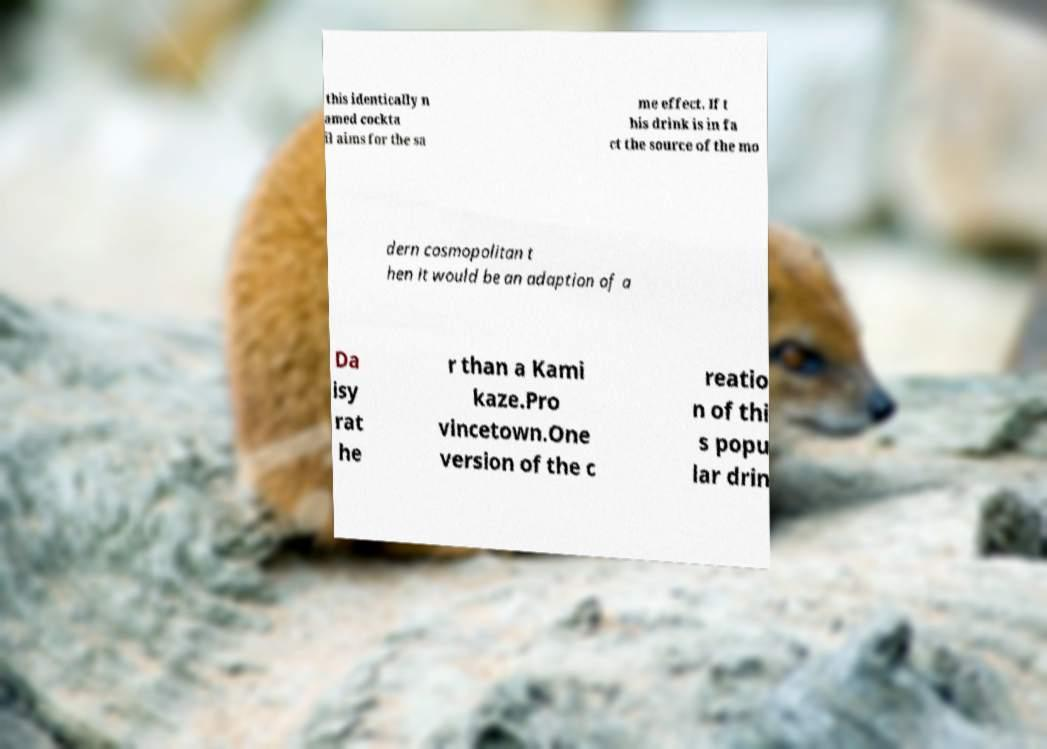Can you read and provide the text displayed in the image?This photo seems to have some interesting text. Can you extract and type it out for me? this identically n amed cockta il aims for the sa me effect. If t his drink is in fa ct the source of the mo dern cosmopolitan t hen it would be an adaption of a Da isy rat he r than a Kami kaze.Pro vincetown.One version of the c reatio n of thi s popu lar drin 